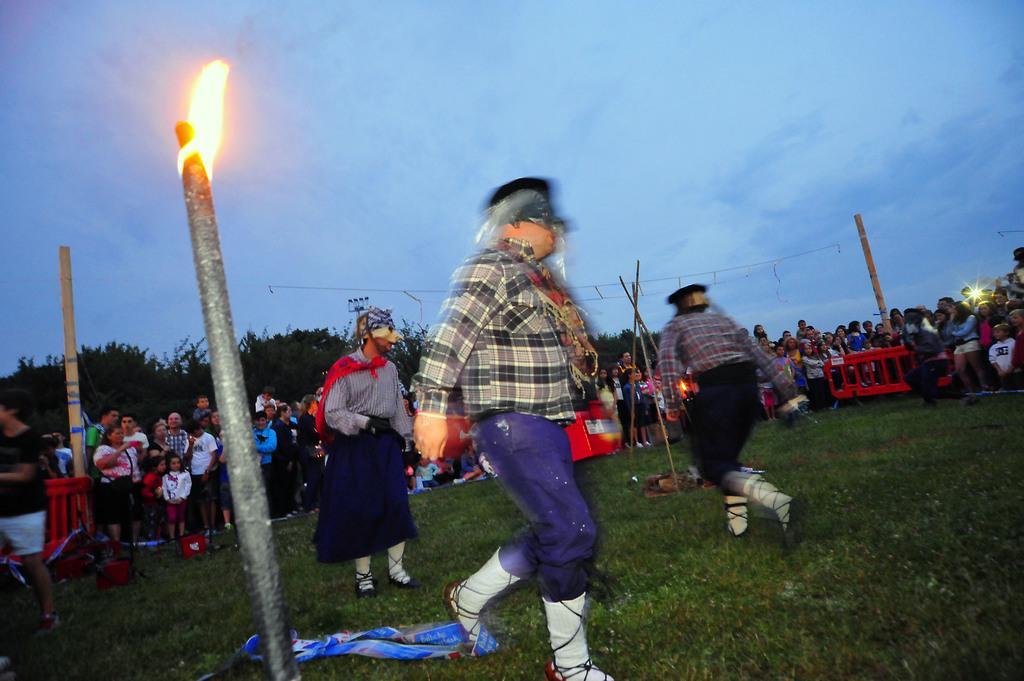Can you describe this image briefly? In this picture we can see group of people, they are standing on the grass, in the background we can see few barricades, trees and clouds, on the left side of the image we can see fire. 